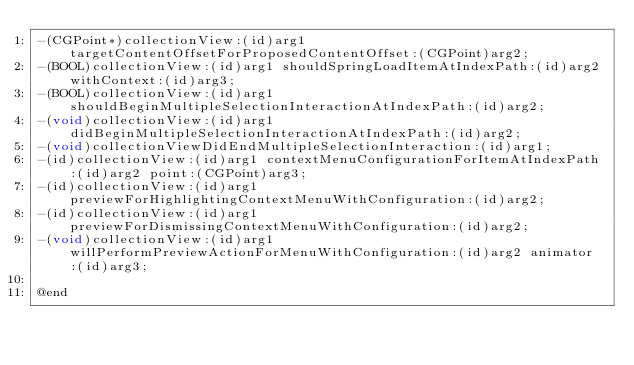Convert code to text. <code><loc_0><loc_0><loc_500><loc_500><_C_>-(CGPoint*)collectionView:(id)arg1 targetContentOffsetForProposedContentOffset:(CGPoint)arg2;
-(BOOL)collectionView:(id)arg1 shouldSpringLoadItemAtIndexPath:(id)arg2 withContext:(id)arg3;
-(BOOL)collectionView:(id)arg1 shouldBeginMultipleSelectionInteractionAtIndexPath:(id)arg2;
-(void)collectionView:(id)arg1 didBeginMultipleSelectionInteractionAtIndexPath:(id)arg2;
-(void)collectionViewDidEndMultipleSelectionInteraction:(id)arg1;
-(id)collectionView:(id)arg1 contextMenuConfigurationForItemAtIndexPath:(id)arg2 point:(CGPoint)arg3;
-(id)collectionView:(id)arg1 previewForHighlightingContextMenuWithConfiguration:(id)arg2;
-(id)collectionView:(id)arg1 previewForDismissingContextMenuWithConfiguration:(id)arg2;
-(void)collectionView:(id)arg1 willPerformPreviewActionForMenuWithConfiguration:(id)arg2 animator:(id)arg3;

@end

</code> 